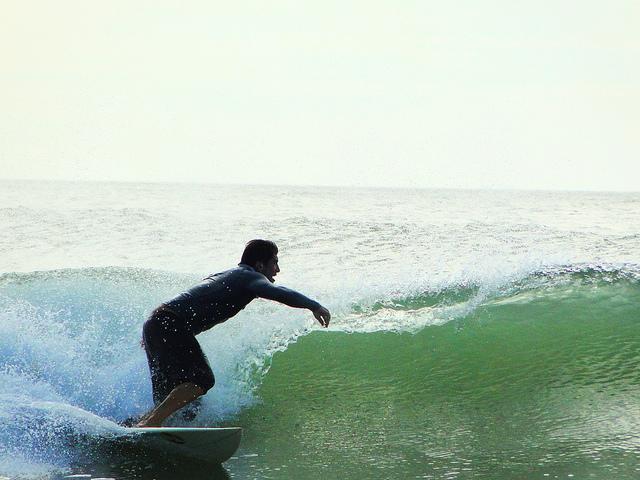How many suitcases are in this photo?
Give a very brief answer. 0. 